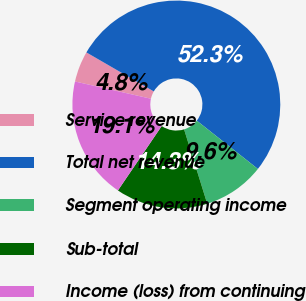Convert chart. <chart><loc_0><loc_0><loc_500><loc_500><pie_chart><fcel>Service revenue<fcel>Total net revenue<fcel>Segment operating income<fcel>Sub-total<fcel>Income (loss) from continuing<nl><fcel>4.8%<fcel>52.29%<fcel>9.55%<fcel>14.3%<fcel>19.05%<nl></chart> 